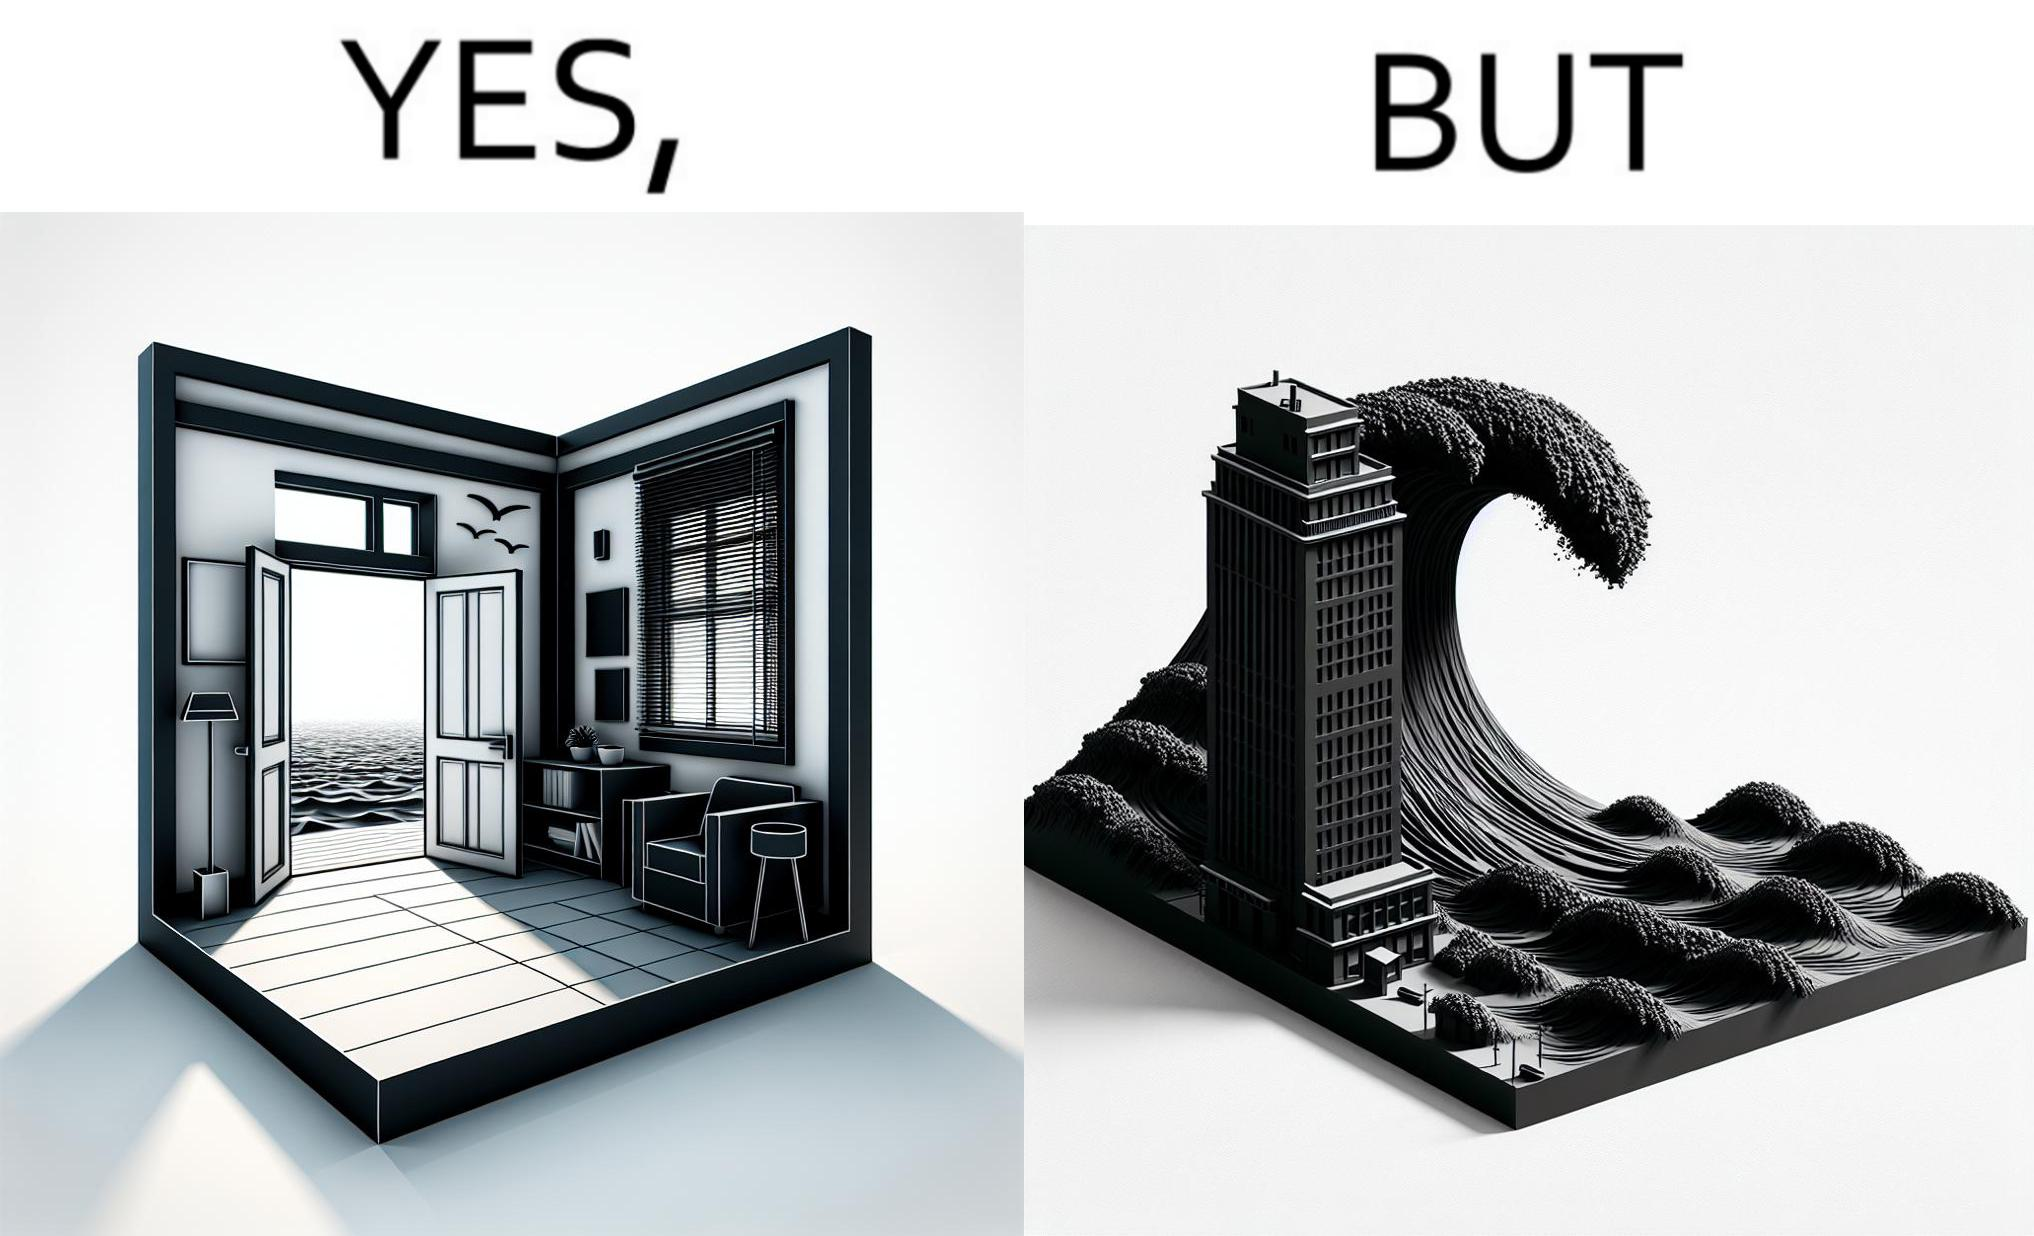Is this image satirical or non-satirical? Yes, this image is satirical. 